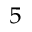Convert formula to latex. <formula><loc_0><loc_0><loc_500><loc_500>^ { 5 }</formula> 